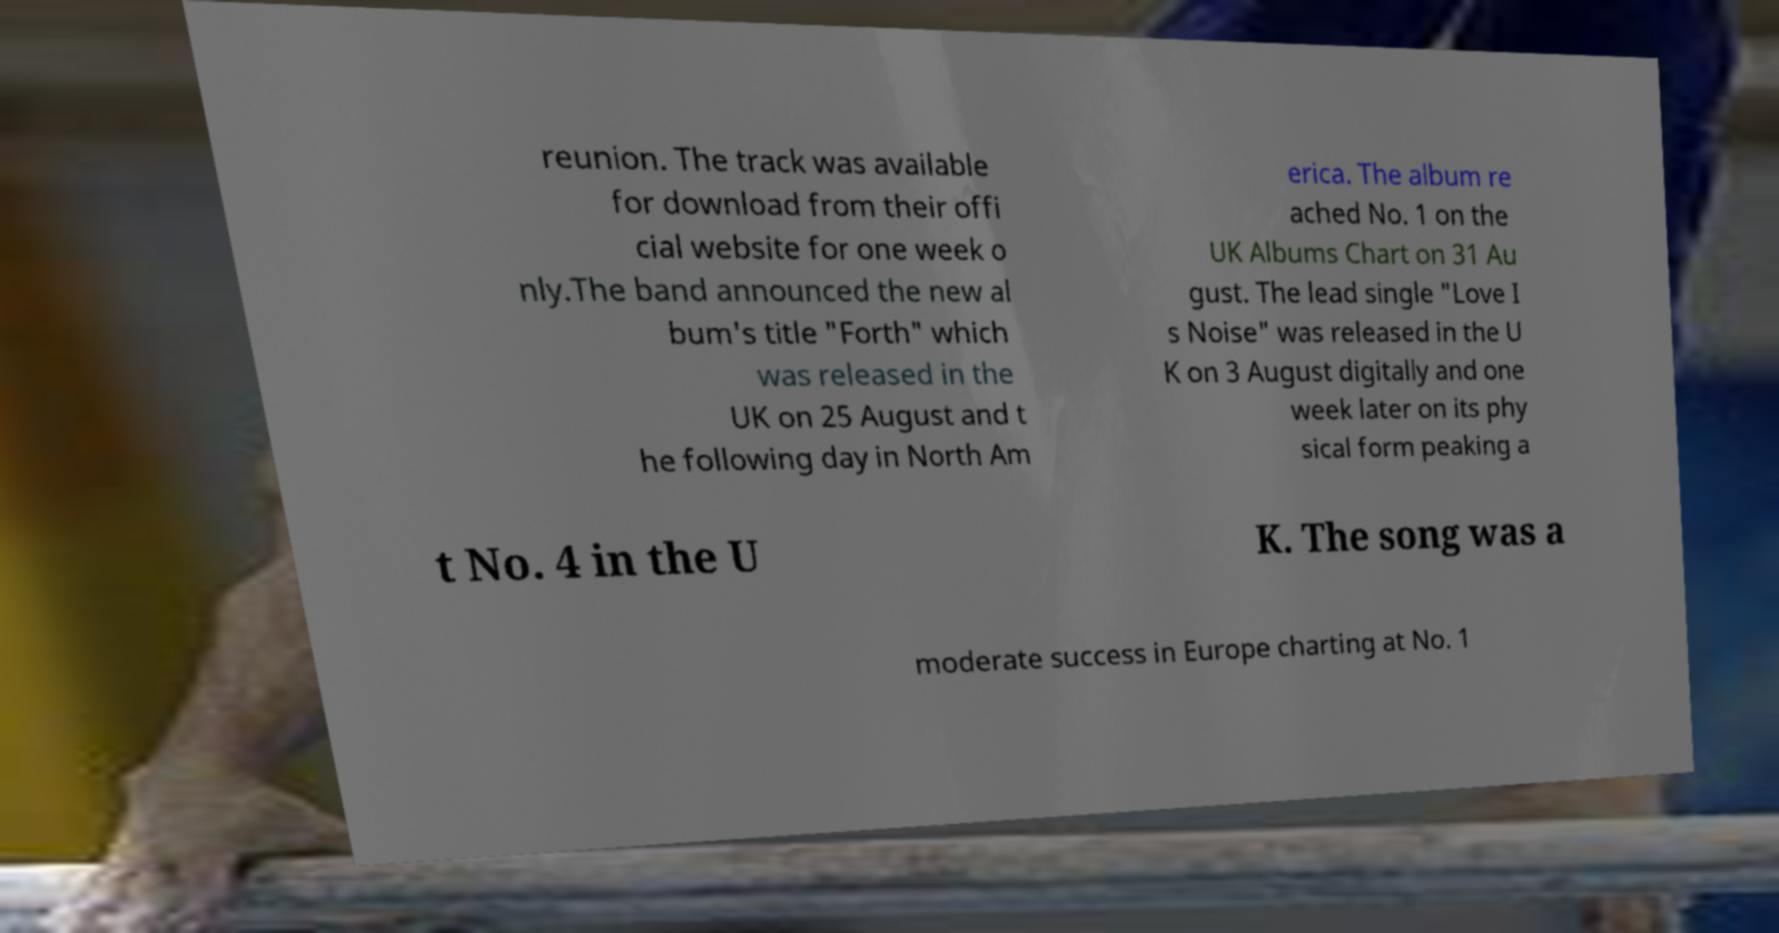What messages or text are displayed in this image? I need them in a readable, typed format. reunion. The track was available for download from their offi cial website for one week o nly.The band announced the new al bum's title "Forth" which was released in the UK on 25 August and t he following day in North Am erica. The album re ached No. 1 on the UK Albums Chart on 31 Au gust. The lead single "Love I s Noise" was released in the U K on 3 August digitally and one week later on its phy sical form peaking a t No. 4 in the U K. The song was a moderate success in Europe charting at No. 1 